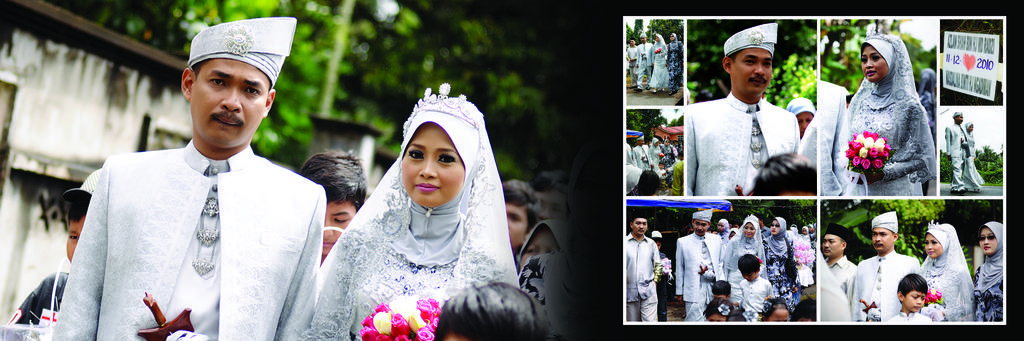Who or what can be seen in the image? There are people in the image. What else is present in the image besides the people? There are flowers in the image. Can you describe the background of the image? The background of the image is blurry. What can be seen in the distance in the image? There is a wall and trees in the background of the image. What type of ant is crawling on the minister's memory in the image? There is no ant or minister present in the image, and the concept of "memory" is not applicable to an image. 